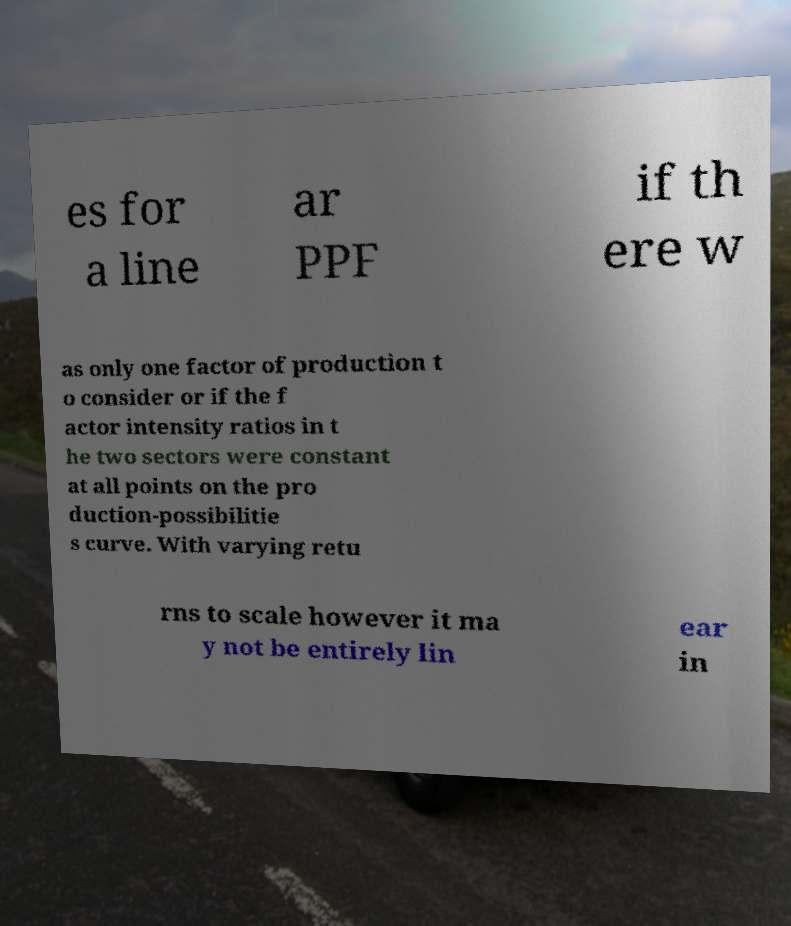I need the written content from this picture converted into text. Can you do that? es for a line ar PPF if th ere w as only one factor of production t o consider or if the f actor intensity ratios in t he two sectors were constant at all points on the pro duction-possibilitie s curve. With varying retu rns to scale however it ma y not be entirely lin ear in 